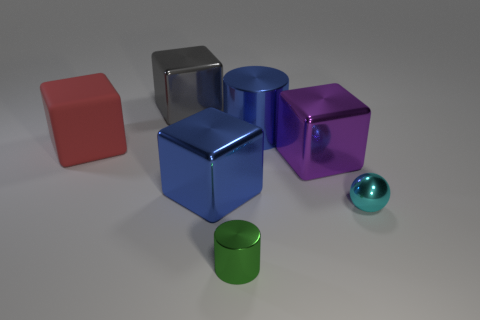Subtract all purple cubes. Subtract all blue cylinders. How many cubes are left? 3 Add 3 large gray cubes. How many objects exist? 10 Subtract all cubes. How many objects are left? 3 Subtract 0 gray spheres. How many objects are left? 7 Subtract all cyan shiny cubes. Subtract all large blue metallic cubes. How many objects are left? 6 Add 2 red things. How many red things are left? 3 Add 1 purple rubber cubes. How many purple rubber cubes exist? 1 